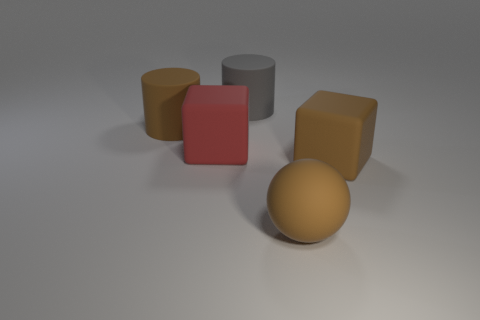Is the size of the cylinder that is on the right side of the red block the same as the big brown sphere?
Offer a very short reply. Yes. What number of tiny things are green shiny balls or brown rubber blocks?
Provide a succinct answer. 0. Are there any large rubber cubes of the same color as the sphere?
Keep it short and to the point. Yes. The gray object that is the same size as the brown matte block is what shape?
Make the answer very short. Cylinder. There is a block to the right of the brown sphere; is its color the same as the large rubber sphere?
Provide a succinct answer. Yes. What number of objects are big rubber objects on the right side of the big brown matte sphere or big matte balls?
Your response must be concise. 2. Is the number of big gray matte cylinders that are in front of the rubber ball greater than the number of large brown objects that are left of the brown rubber block?
Give a very brief answer. No. Does the big gray thing have the same material as the brown sphere?
Provide a short and direct response. Yes. There is a object that is both right of the red rubber block and to the left of the brown sphere; what shape is it?
Offer a terse response. Cylinder. The red thing that is made of the same material as the ball is what shape?
Provide a short and direct response. Cube. 